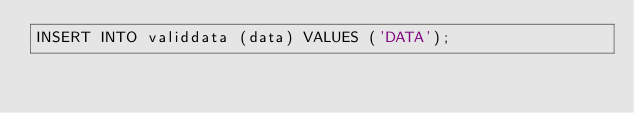Convert code to text. <code><loc_0><loc_0><loc_500><loc_500><_SQL_>INSERT INTO validdata (data) VALUES ('DATA');</code> 